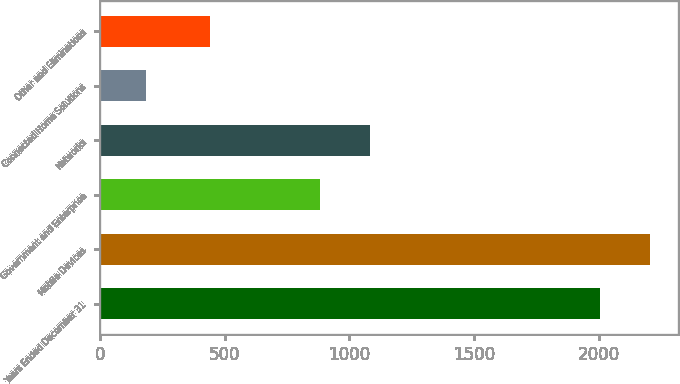<chart> <loc_0><loc_0><loc_500><loc_500><bar_chart><fcel>Years Ended December 31<fcel>Mobile Devices<fcel>Government and Enterprise<fcel>Networks<fcel>Connected Home Solutions<fcel>Other and Eliminations<nl><fcel>2005<fcel>2206.3<fcel>882<fcel>1083.3<fcel>185<fcel>441<nl></chart> 